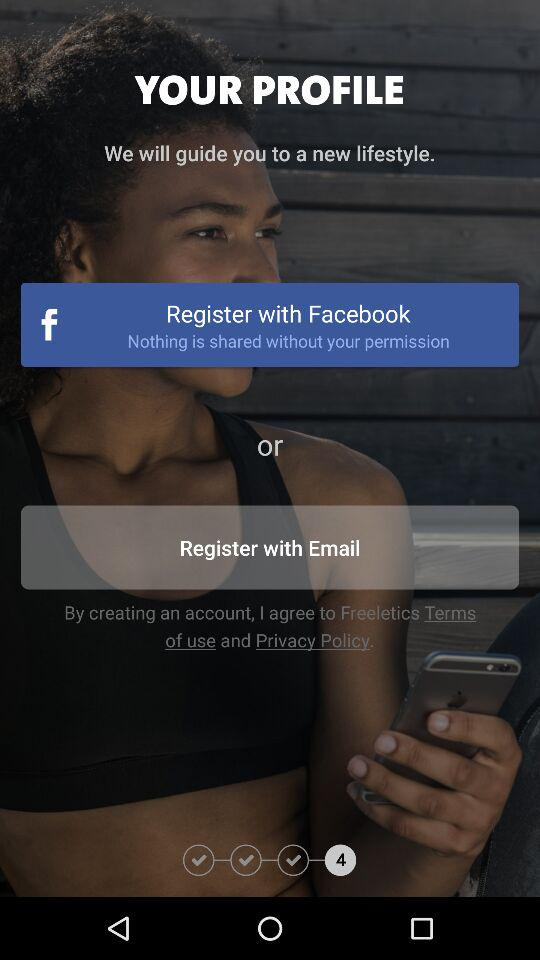Which are the different registration options? The different registration options are "Facebook" and "Email". 